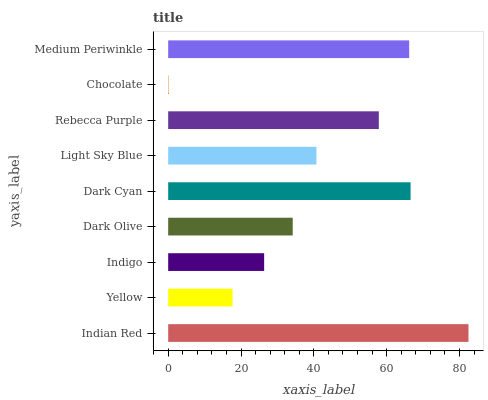Is Chocolate the minimum?
Answer yes or no. Yes. Is Indian Red the maximum?
Answer yes or no. Yes. Is Yellow the minimum?
Answer yes or no. No. Is Yellow the maximum?
Answer yes or no. No. Is Indian Red greater than Yellow?
Answer yes or no. Yes. Is Yellow less than Indian Red?
Answer yes or no. Yes. Is Yellow greater than Indian Red?
Answer yes or no. No. Is Indian Red less than Yellow?
Answer yes or no. No. Is Light Sky Blue the high median?
Answer yes or no. Yes. Is Light Sky Blue the low median?
Answer yes or no. Yes. Is Yellow the high median?
Answer yes or no. No. Is Rebecca Purple the low median?
Answer yes or no. No. 